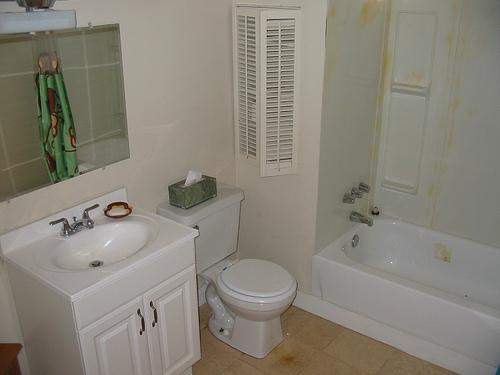Is this a large bathroom?
Give a very brief answer. Yes. What is the only colorful item in this picture?
Concise answer only. Towel. Is this bathroom finished?
Be succinct. No. What is on the toilet?
Answer briefly. Tissues. Where is the kleenex?
Quick response, please. On toilet. How many bars of soap are visible?
Be succinct. 1. How many types of soap are on the counter?
Give a very brief answer. 1. Is there facial wash on the counter?
Quick response, please. No. What kind of flooring is in the room?
Answer briefly. Tile. Is the toilet lid open or closed?
Answer briefly. Closed. What color are the towels?
Short answer required. Green. Is the toilet lid up or down?
Concise answer only. Down. What is this kitchen fixture used for?
Give a very brief answer. Pooping. 